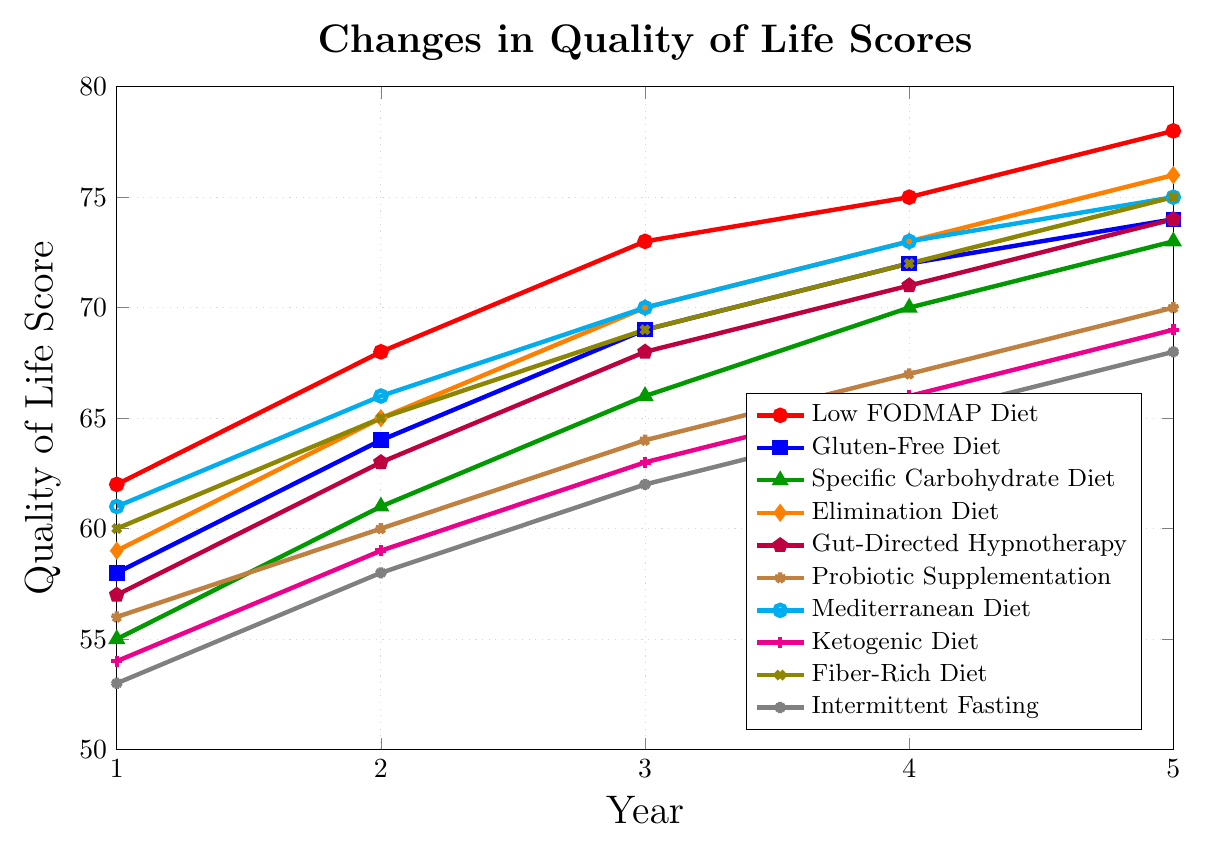What dietary intervention showed the highest improvement in quality of life score by Year 5? To determine this, we need to compare the quality of life scores in Year 5 for all dietary interventions. Low FODMAP Diet has the highest score of 78 in Year 5.
Answer: Low FODMAP Diet Which dietary intervention had the least improvement in quality of life over the 5-year period? We calculate the difference in scores between Year 5 and Year 1 for each intervention. Intermittent Fasting showed the least improvement with a change of 15 (68 - 53).
Answer: Intermittent Fasting What is the average quality of life score for the Mediterranean Diet across all five years? Add the scores for the Mediterranean Diet from Year 1 to Year 5 and then divide by 5: (61 + 66 + 70 + 73 + 75) / 5 = 69
Answer: 69 Compare the quality of life scores of the Low FODMAP Diet and Gluten-Free Diet in Year 3. Which one is higher and by how much? The score for the Low FODMAP Diet in Year 3 is 73 and for the Gluten-Free Diet, it is 69. The difference is 73 - 69 = 4.
Answer: Low FODMAP Diet by 4 points Which intervention showed a consistent increase in quality of life scores every year? Review the score for each intervention from Year 1 to Year 5. The Low FODMAP Diet scores increased every year: 62, 68, 73, 75, 78.
Answer: Low FODMAP Diet What is the total increase in quality of life score for Probiotic Supplementation from Year 1 to Year 5? Subtract the Year 1 score from the Year 5 score for the Probiotic Supplementation diet: 70 - 56 = 14.
Answer: 14 Between the Specific Carbohydrate Diet and the Ketogenic Diet, which had a higher quality of life score in Year 2? The score for the Specific Carbohydrate Diet in Year 2 is 61 and for the Ketogenic Diet, it is 59. 61 is higher than 59.
Answer: Specific Carbohydrate Diet Compare the range of scores over the five years for the Elimination Diet and the Mediterranean Diet. Which has the wider range? The range is found by subtracting the lowest score from the highest score. For Elimination Diet: 76 - 59 = 17. For Mediterranean Diet: 75 - 61 = 14. Elimination Diet has a wider range by 3 points.
Answer: Elimination Diet What is the sum of the quality of life scores for Gut-Directed Hypnotherapy in Year 1 and Year 5? Add the scores for Gut-Directed Hypnotherapy in Year 1 and Year 5: 57 + 74 = 131.
Answer: 131 